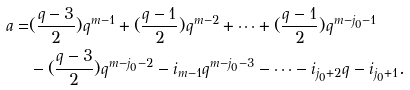Convert formula to latex. <formula><loc_0><loc_0><loc_500><loc_500>a = & ( \frac { q - 3 } { 2 } ) q ^ { m - 1 } + ( \frac { q - 1 } { 2 } ) q ^ { m - 2 } + \cdots + ( \frac { q - 1 } { 2 } ) q ^ { m - j _ { 0 } - 1 } \\ & - ( \frac { q - 3 } { 2 } ) q ^ { m - j _ { 0 } - 2 } - i _ { m - 1 } q ^ { m - j _ { 0 } - 3 } - \cdots - i _ { j _ { 0 } + 2 } q - i _ { j _ { 0 } + 1 } .</formula> 